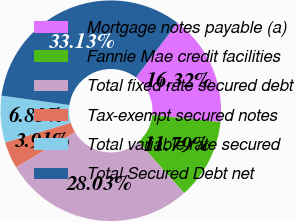Convert chart. <chart><loc_0><loc_0><loc_500><loc_500><pie_chart><fcel>Mortgage notes payable (a)<fcel>Fannie Mae credit facilities<fcel>Total fixed rate secured debt<fcel>Tax-exempt secured notes<fcel>Total variable rate secured<fcel>Total Secured Debt net<nl><fcel>16.32%<fcel>11.79%<fcel>28.03%<fcel>3.91%<fcel>6.83%<fcel>33.13%<nl></chart> 